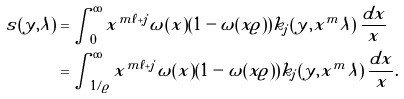<formula> <loc_0><loc_0><loc_500><loc_500>s ( y , \lambda ) & = \int _ { 0 } ^ { \infty } x ^ { m \ell + j } \omega ( x ) ( 1 - \omega ( x \varrho ) ) k _ { j } ( y , x ^ { m } \lambda ) \, \frac { d x } { x } \\ & = \int _ { 1 / \varrho } ^ { \infty } x ^ { m \ell + j } \omega ( x ) ( 1 - \omega ( x \varrho ) ) k _ { j } ( y , x ^ { m } \lambda ) \, \frac { d x } { x } .</formula> 